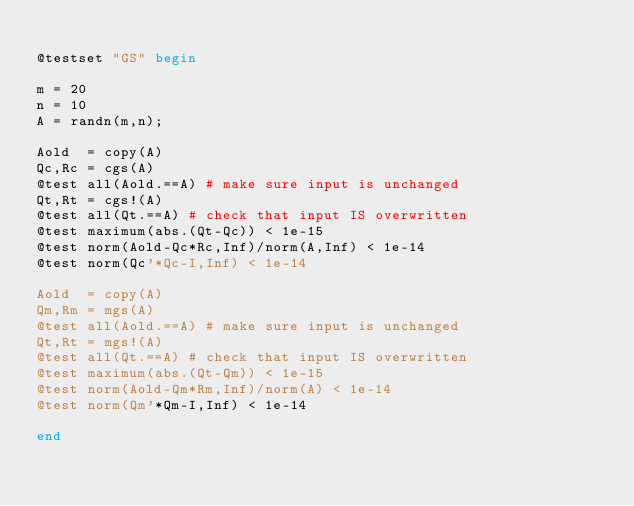<code> <loc_0><loc_0><loc_500><loc_500><_Julia_>
@testset "GS" begin

m = 20
n = 10
A = randn(m,n);

Aold  = copy(A)
Qc,Rc = cgs(A)
@test all(Aold.==A) # make sure input is unchanged
Qt,Rt = cgs!(A)
@test all(Qt.==A) # check that input IS overwritten
@test maximum(abs.(Qt-Qc)) < 1e-15
@test norm(Aold-Qc*Rc,Inf)/norm(A,Inf) < 1e-14
@test norm(Qc'*Qc-I,Inf) < 1e-14

Aold  = copy(A)
Qm,Rm = mgs(A)
@test all(Aold.==A) # make sure input is unchanged
Qt,Rt = mgs!(A)
@test all(Qt.==A) # check that input IS overwritten
@test maximum(abs.(Qt-Qm)) < 1e-15
@test norm(Aold-Qm*Rm,Inf)/norm(A) < 1e-14
@test norm(Qm'*Qm-I,Inf) < 1e-14

end
</code> 